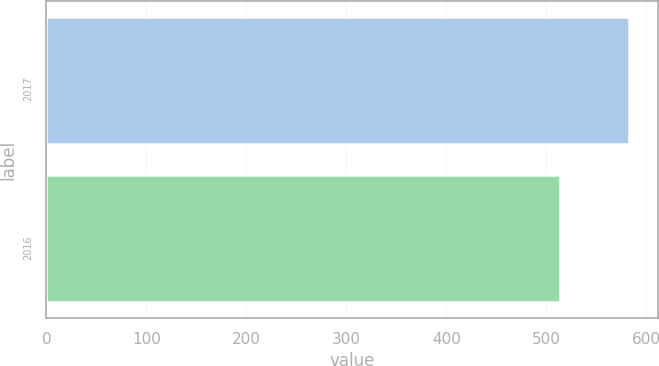Convert chart. <chart><loc_0><loc_0><loc_500><loc_500><bar_chart><fcel>2017<fcel>2016<nl><fcel>583<fcel>514<nl></chart> 